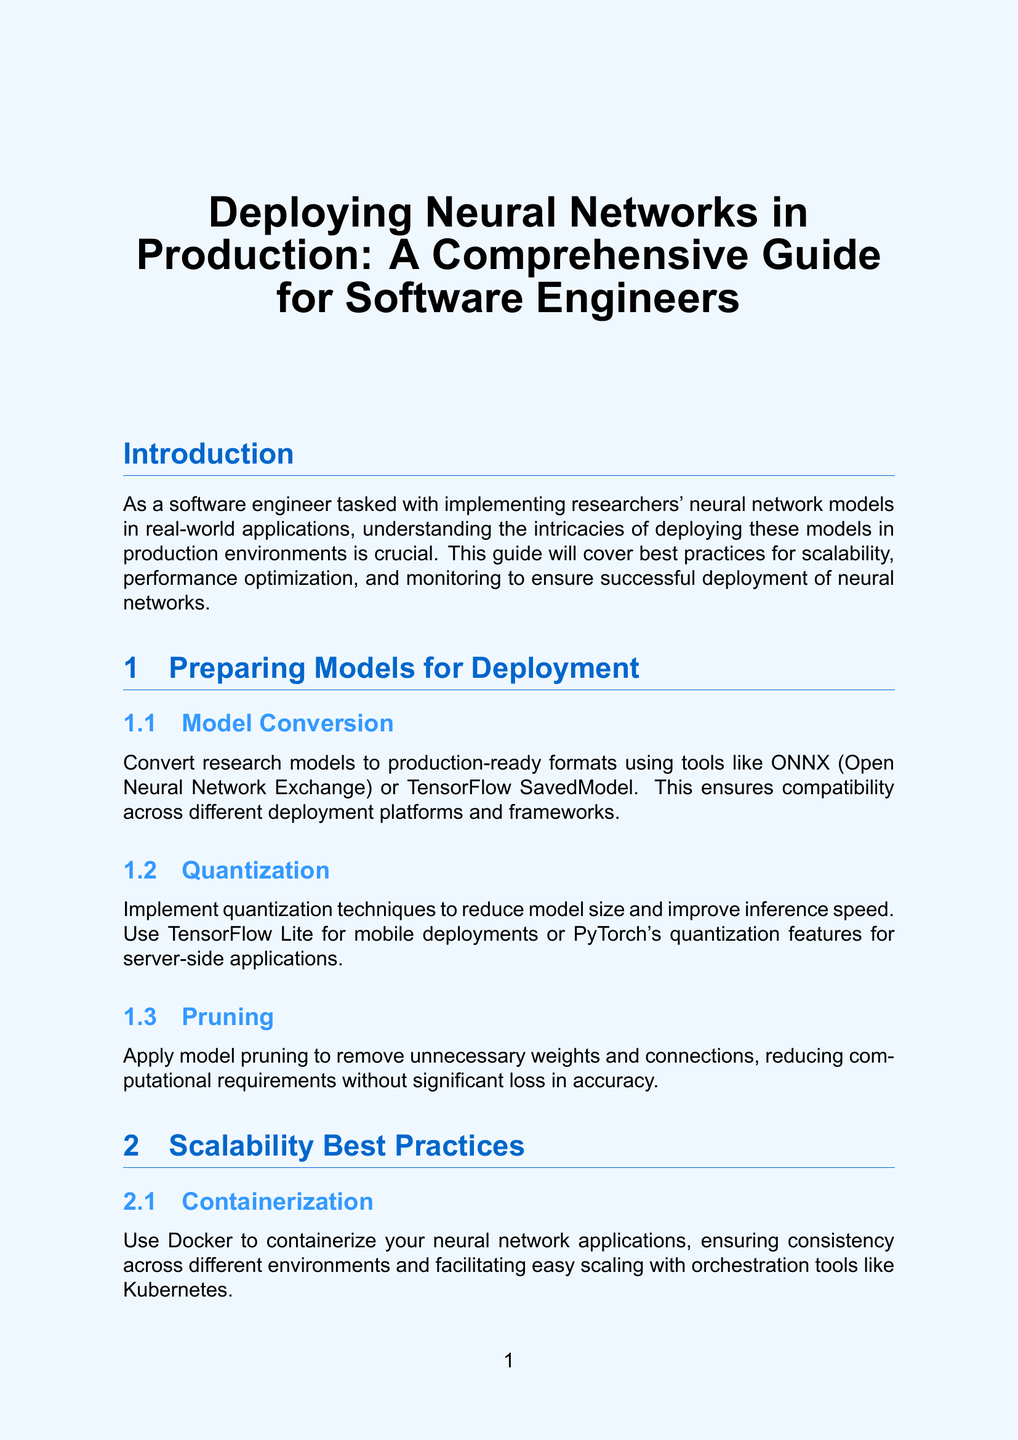what is the title of the document? The title is mentioned at the beginning of the document.
Answer: Deploying Neural Networks in Production: A Comprehensive Guide for Software Engineers what are the three main areas covered in the guide? The introduction highlights the three main areas that the guide will cover.
Answer: scalability, performance optimization, and monitoring which tool is suggested for model conversion? The document specifically names a tool for model conversion under the "Model Conversion" section.
Answer: ONNX what technique can reduce model size? The "Quantization" subsection mentions a technique aimed at reducing model size.
Answer: Quantization which platform is recommended for automated testing pipelines? The "Automated Testing" subsection specifies a platform for testing pipelines.
Answer: Jenkins what is the purpose of using Docker according to the guide? The "Containerization" subsection explains the role of Docker in the deployment process.
Answer: containerize applications what is one method for caching results? In the "Caching" subsection, a mechanism for caching results is mentioned.
Answer: Redis name one alerting tool mentioned in the document. The "Alerting" subsection lists tools for setting up alerts.
Answer: PagerDuty what is a security measure listed under Input Validation? The "Input Validation" subsection specifies a focus area to prevent certain attacks.
Answer: robust input validation 